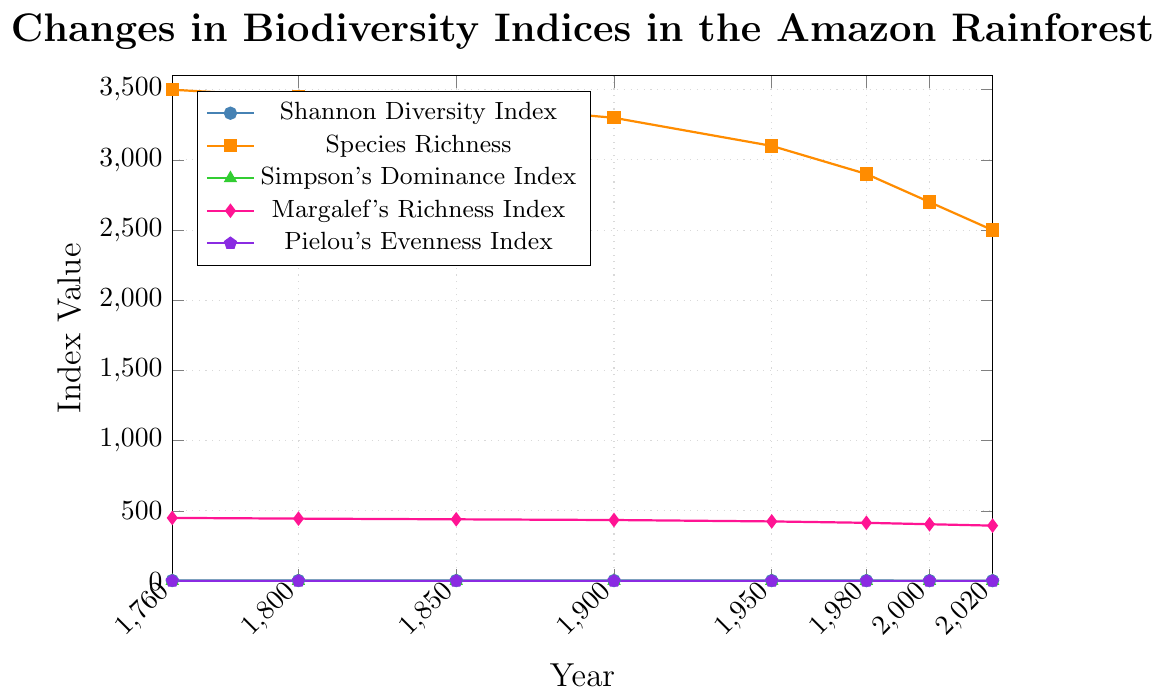what is the trend of the Shannon Diversity Index from 1760 to 2020? The Shannon Diversity Index is plotted with color marks. By observing the trend, we can see that it decreases gradually from 1760 to 2020.
Answer: decreasing How does the Species Richness index change between 1900 and 1950? By observing the orange line in the plot, the Species Richness decreases from 3300 in 1900 to 3100 in 1950.
Answer: It decreases Which index shows the steepest decline from 1980 to 2020? By comparing the slopes of all the indices within the period 1980 to 2020, the steepest decline is observed in the Species Richness index.
Answer: Species Richness Between which two consecutive periods does Margalef's Richness Index show the smallest decrease? By comparing the differences between consecutive points in the pink line for Margalef's Richness Index, the smallest decrease is between 1900 and 1950 (from 435 to 425).
Answer: 1900 and 1950 What is the average value of the Simpson's Dominance Index over all years? To find the average value, sum all the values (0.95 + 0.94 + 0.93 + 0.92 + 0.90 + 0.88 + 0.86 + 0.84 = 7.22) and divide by the number of years (8). 7.22 / 8 = 0.9025
Answer: 0.9025 How much does Pielou's Evenness Index decrease from 1760 to 2020? The value for Pielou's Evenness Index in 1760 is 0.88 and in 2020 is 0.77. The decrease is 0.88 - 0.77 = 0.11.
Answer: 0.11 During which century (1800s or 1900s) did the Shannon Diversity Index drop more significantly? The Shannon Diversity Index dropped from 4.1 to 4.0 (0.1) in the 1800s and from 4.0 to 3.5 (0.5) in the 1900s. The drop was more significant in the 1900s.
Answer: 1900s Identify the year when the Shannon Diversity Index and Simpson's Dominance Index were closest. Observing the blue and green lines, the two indices are closest in 1800, where Shannon is 4.1 and Simpson's Dominance is 0.94.
Answer: 1800 